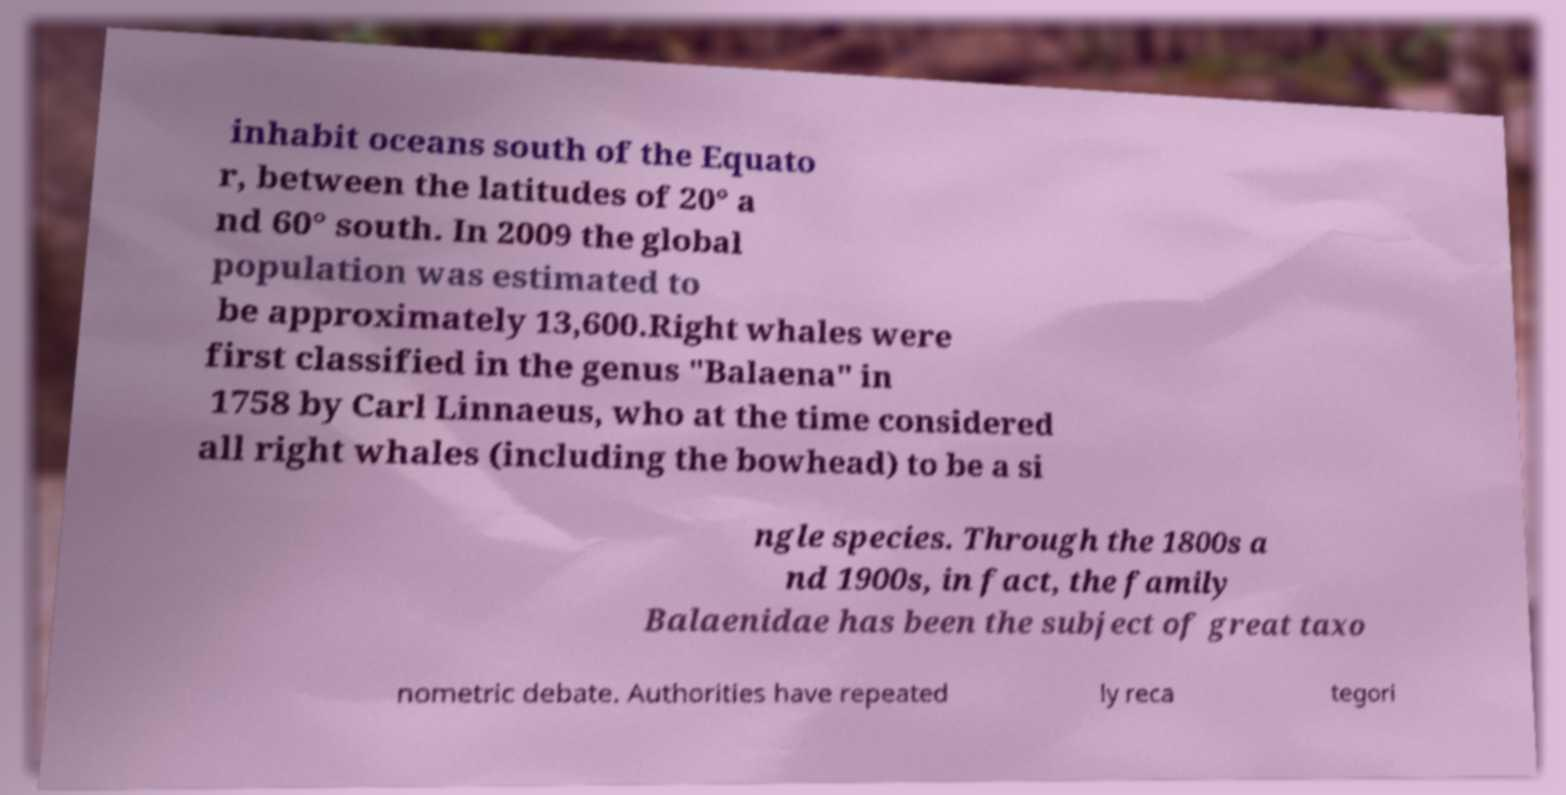Can you accurately transcribe the text from the provided image for me? inhabit oceans south of the Equato r, between the latitudes of 20° a nd 60° south. In 2009 the global population was estimated to be approximately 13,600.Right whales were first classified in the genus "Balaena" in 1758 by Carl Linnaeus, who at the time considered all right whales (including the bowhead) to be a si ngle species. Through the 1800s a nd 1900s, in fact, the family Balaenidae has been the subject of great taxo nometric debate. Authorities have repeated ly reca tegori 